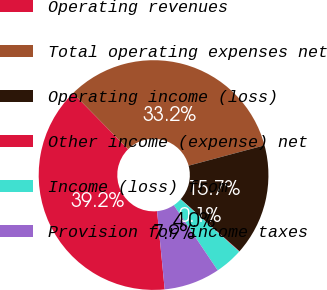Convert chart. <chart><loc_0><loc_0><loc_500><loc_500><pie_chart><fcel>Operating revenues<fcel>Total operating expenses net<fcel>Operating income (loss)<fcel>Other income (expense) net<fcel>Income (loss) from<fcel>Provision for income taxes<nl><fcel>39.17%<fcel>33.2%<fcel>15.71%<fcel>0.06%<fcel>3.97%<fcel>7.88%<nl></chart> 